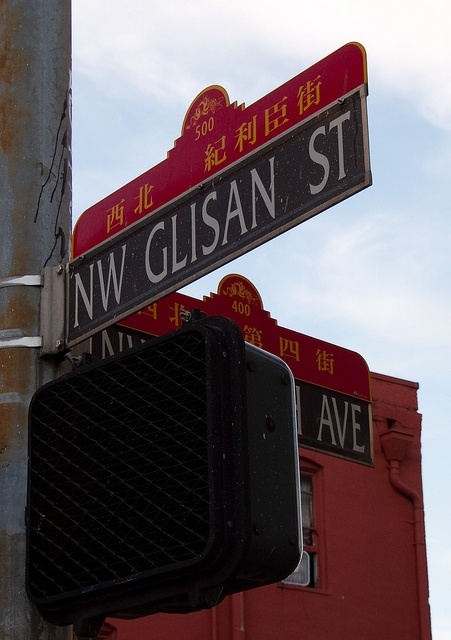Describe the objects in this image and their specific colors. I can see a traffic light in maroon, black, gray, and darkgray tones in this image. 